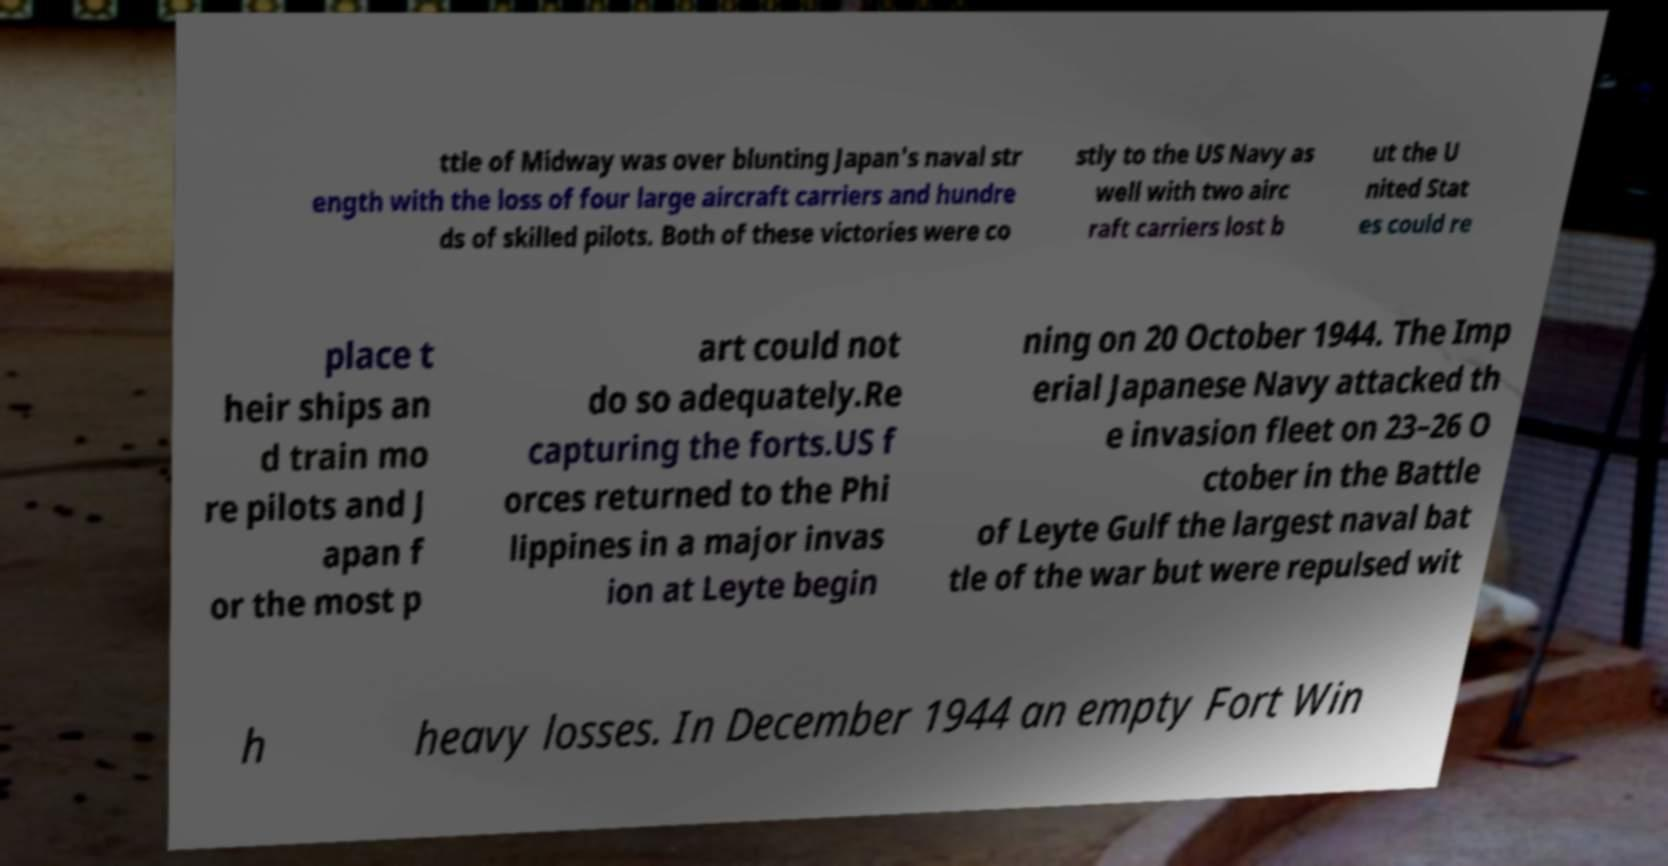What messages or text are displayed in this image? I need them in a readable, typed format. ttle of Midway was over blunting Japan's naval str ength with the loss of four large aircraft carriers and hundre ds of skilled pilots. Both of these victories were co stly to the US Navy as well with two airc raft carriers lost b ut the U nited Stat es could re place t heir ships an d train mo re pilots and J apan f or the most p art could not do so adequately.Re capturing the forts.US f orces returned to the Phi lippines in a major invas ion at Leyte begin ning on 20 October 1944. The Imp erial Japanese Navy attacked th e invasion fleet on 23–26 O ctober in the Battle of Leyte Gulf the largest naval bat tle of the war but were repulsed wit h heavy losses. In December 1944 an empty Fort Win 